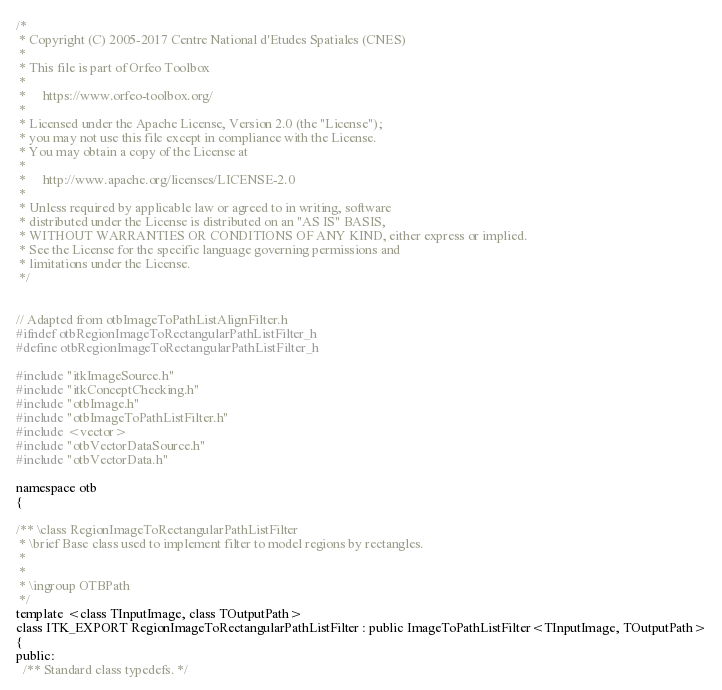<code> <loc_0><loc_0><loc_500><loc_500><_C_>/*
 * Copyright (C) 2005-2017 Centre National d'Etudes Spatiales (CNES)
 *
 * This file is part of Orfeo Toolbox
 *
 *     https://www.orfeo-toolbox.org/
 *
 * Licensed under the Apache License, Version 2.0 (the "License");
 * you may not use this file except in compliance with the License.
 * You may obtain a copy of the License at
 *
 *     http://www.apache.org/licenses/LICENSE-2.0
 *
 * Unless required by applicable law or agreed to in writing, software
 * distributed under the License is distributed on an "AS IS" BASIS,
 * WITHOUT WARRANTIES OR CONDITIONS OF ANY KIND, either express or implied.
 * See the License for the specific language governing permissions and
 * limitations under the License.
 */


// Adapted from otbImageToPathListAlignFilter.h
#ifndef otbRegionImageToRectangularPathListFilter_h
#define otbRegionImageToRectangularPathListFilter_h

#include "itkImageSource.h"
#include "itkConceptChecking.h"
#include "otbImage.h"
#include "otbImageToPathListFilter.h"
#include <vector>
#include "otbVectorDataSource.h"
#include "otbVectorData.h"

namespace otb
{

/** \class RegionImageToRectangularPathListFilter
 * \brief Base class used to implement filter to model regions by rectangles.
 *
 *
 * \ingroup OTBPath
 */
template <class TInputImage, class TOutputPath>
class ITK_EXPORT RegionImageToRectangularPathListFilter : public ImageToPathListFilter<TInputImage, TOutputPath>
{
public:
  /** Standard class typedefs. */</code> 